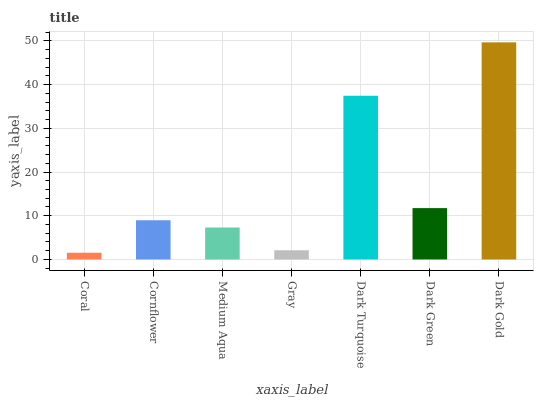Is Cornflower the minimum?
Answer yes or no. No. Is Cornflower the maximum?
Answer yes or no. No. Is Cornflower greater than Coral?
Answer yes or no. Yes. Is Coral less than Cornflower?
Answer yes or no. Yes. Is Coral greater than Cornflower?
Answer yes or no. No. Is Cornflower less than Coral?
Answer yes or no. No. Is Cornflower the high median?
Answer yes or no. Yes. Is Cornflower the low median?
Answer yes or no. Yes. Is Gray the high median?
Answer yes or no. No. Is Gray the low median?
Answer yes or no. No. 